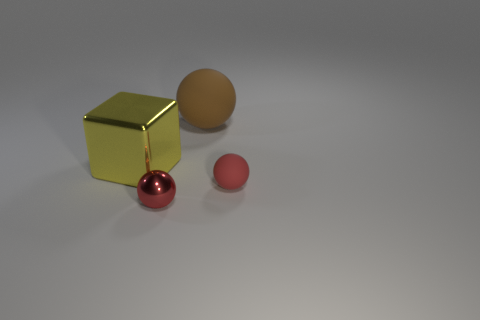Is the size of the red matte ball the same as the brown thing?
Make the answer very short. No. What number of other tiny balls have the same color as the tiny matte ball?
Keep it short and to the point. 1. What is the color of the small sphere on the left side of the red sphere that is to the right of the big rubber object?
Offer a terse response. Red. What color is the sphere that is the same size as the yellow thing?
Provide a succinct answer. Brown. What number of metallic objects are small objects or big yellow blocks?
Provide a short and direct response. 2. What number of red rubber spheres are to the right of the small sphere to the left of the small matte thing?
Ensure brevity in your answer.  1. The matte ball that is the same color as the small metallic ball is what size?
Provide a short and direct response. Small. What number of objects are tiny red metallic spheres or balls that are to the right of the tiny shiny ball?
Keep it short and to the point. 3. Is there a object that has the same material as the block?
Your answer should be very brief. Yes. What number of metal objects are both on the left side of the small metal object and in front of the large yellow shiny thing?
Provide a succinct answer. 0. 